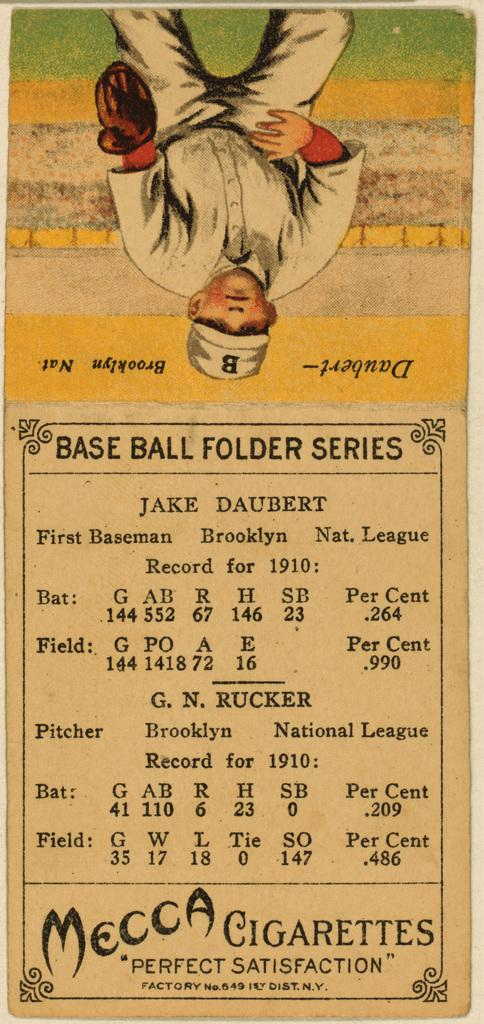What is the main subject of the image? The main subject of the image is a paper. What can be seen in the top part of the image? There is ground, a wall, and a man standing in the top part of the image. Can you describe the man in the image? The man is wearing a cap and gloves. What else is visible in the background of the image? There is text visible in the background of the image. What type of kettle is visible in the image? There is no kettle present in the image. Can you tell me the account number of the man in the image? There is no account number visible in the image. 